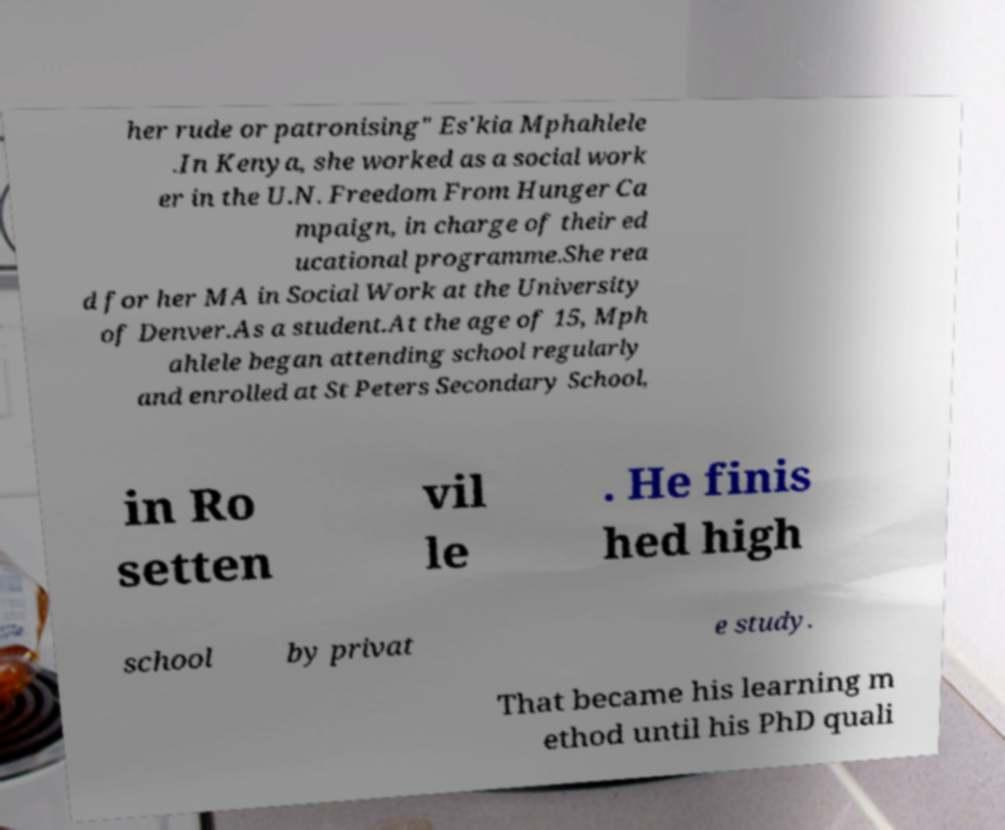I need the written content from this picture converted into text. Can you do that? her rude or patronising" Es'kia Mphahlele .In Kenya, she worked as a social work er in the U.N. Freedom From Hunger Ca mpaign, in charge of their ed ucational programme.She rea d for her MA in Social Work at the University of Denver.As a student.At the age of 15, Mph ahlele began attending school regularly and enrolled at St Peters Secondary School, in Ro setten vil le . He finis hed high school by privat e study. That became his learning m ethod until his PhD quali 